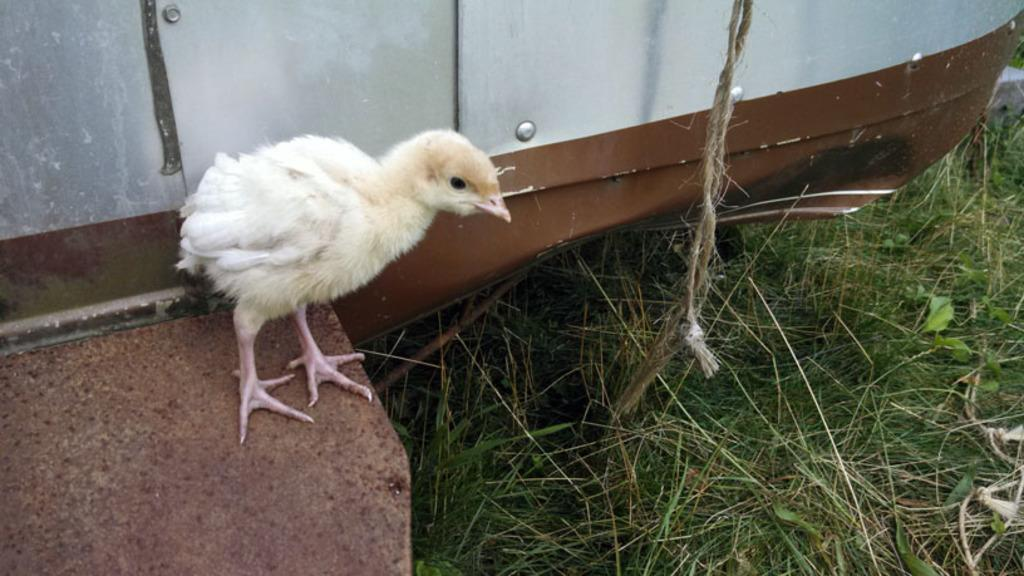What animal can be seen in the picture? There is a chick in the picture. Where is the chick located in the image? The chick is on the left side of the image. What type of vegetation is present in the image? There is green grass in the image. What object can be seen on the right side of the image? There is a rope on the right side of the image. What structure is visible at the top of the image? There appears to be a metal structure object at the top of the image. How many icicles are hanging from the metal structure object in the image? There are no icicles present in the image; it features a chick, green grass, a rope, and a metal structure object. What type of pie is being served on a cushion in the image? There is no pie or cushion present in the image. 